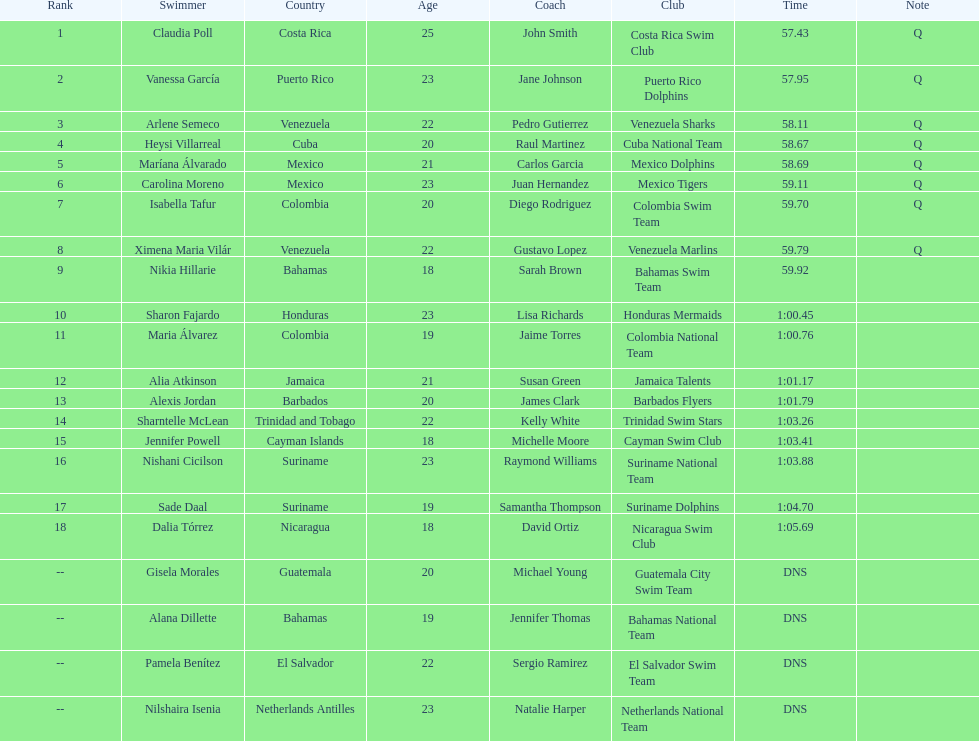How many swimmers are from mexico? 2. 